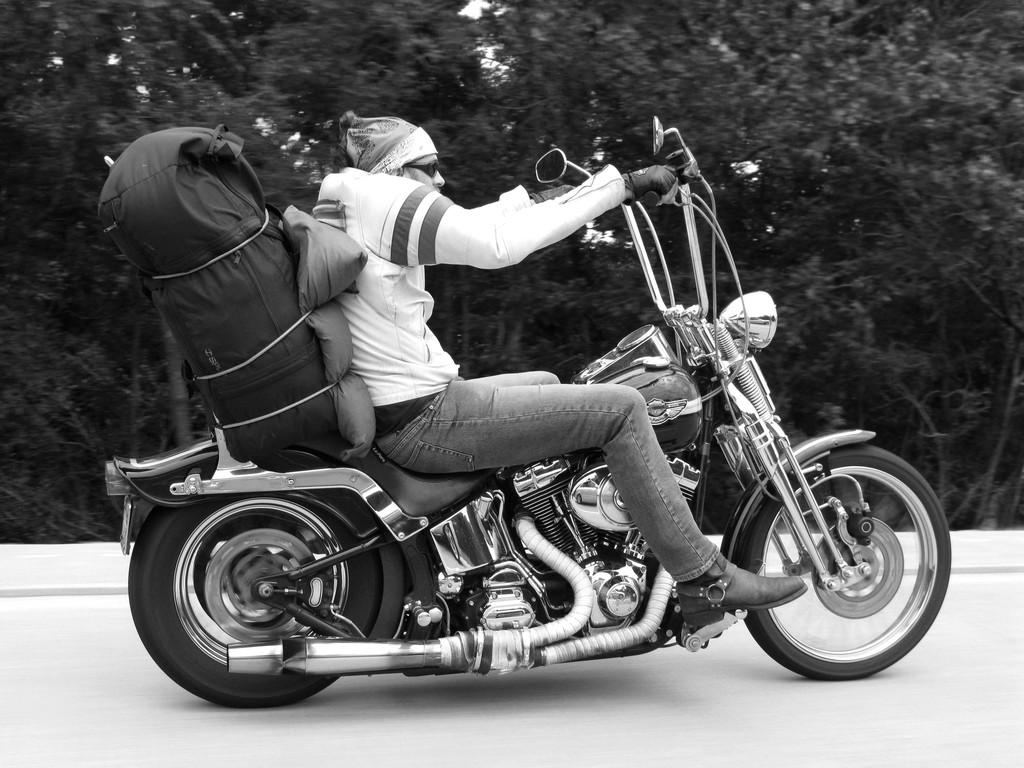What is the color scheme of the image? The image is black and white. What activity is the person in the image engaged in? The person is riding a bike in the image. What is the person carrying on their back? The person is wearing a backpack. What can be seen in the distance behind the person? There are trees in the background of the image. Where is the calendar located in the image? There is no calendar present in the image. What type of sponge can be seen in the image? There is no sponge present in the image. 